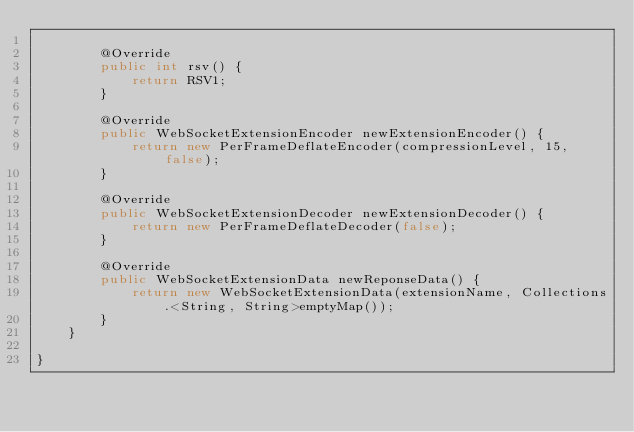<code> <loc_0><loc_0><loc_500><loc_500><_Java_>
        @Override
        public int rsv() {
            return RSV1;
        }

        @Override
        public WebSocketExtensionEncoder newExtensionEncoder() {
            return new PerFrameDeflateEncoder(compressionLevel, 15, false);
        }

        @Override
        public WebSocketExtensionDecoder newExtensionDecoder() {
            return new PerFrameDeflateDecoder(false);
        }

        @Override
        public WebSocketExtensionData newReponseData() {
            return new WebSocketExtensionData(extensionName, Collections.<String, String>emptyMap());
        }
    }

}
</code> 